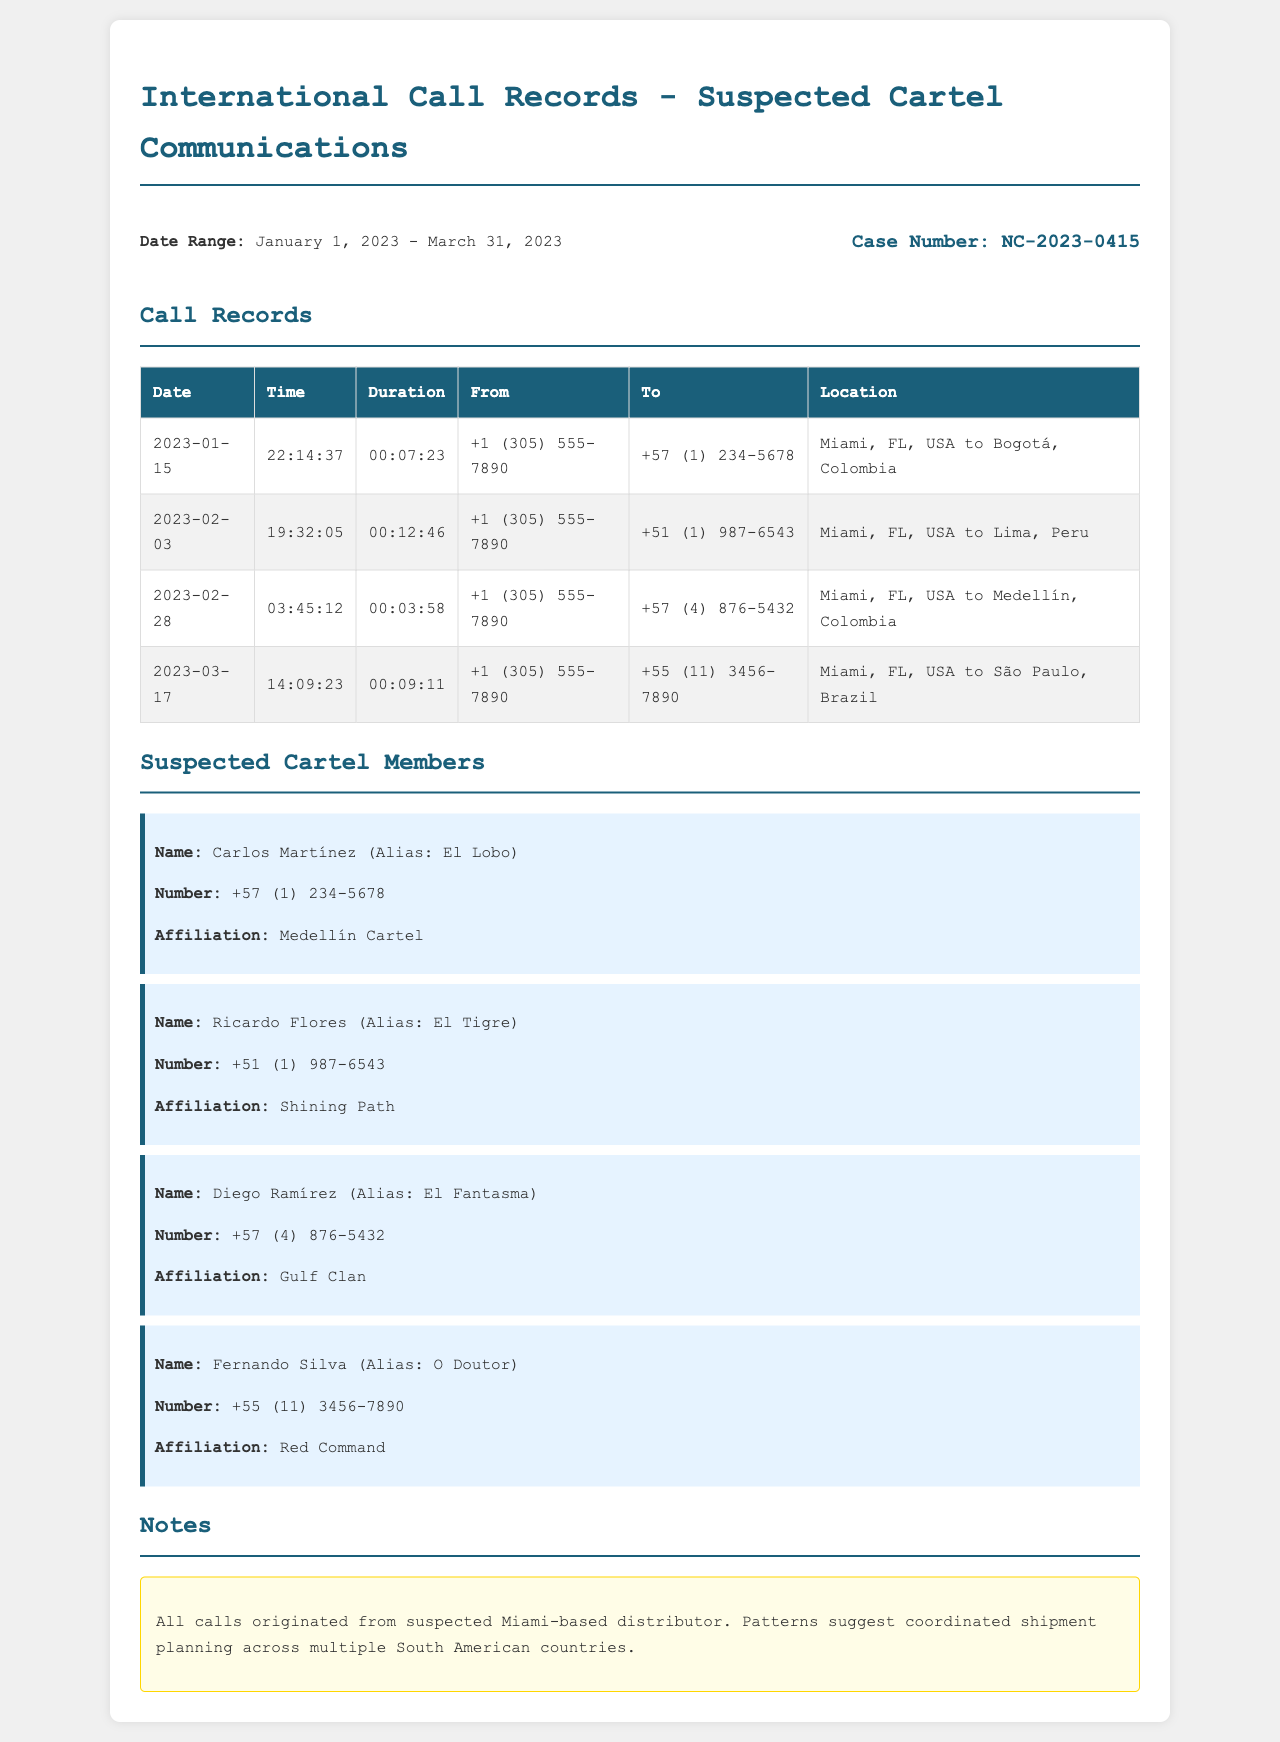what is the case number? The case number is explicitly mentioned in the document header.
Answer: NC-2023-0415 who is the suspect with the alias "El Lobo"? The document provides a specific suspect and their details.
Answer: Carlos Martínez how many calls were made to suspected cartel members in February 2023? There are two call records listed in February 2023.
Answer: 2 which location is connected to the call on March 17, 2023? Each call record lists a location indicating the origin and destination.
Answer: São Paulo, Brazil what is the duration of the call made on January 15, 2023? The duration is specified in the call records for that date.
Answer: 00:07:23 who is affiliated with the Medellín Cartel? The suspects are listed along with their affiliations.
Answer: Carlos Martínez what time was the overall longest call made? The longest call duration can be assessed from the records.
Answer: 19:32:05 which suspect has the contact number +51 (1) 987-6543? The contact numbers of the suspects are provided in their details.
Answer: Ricardo Flores 